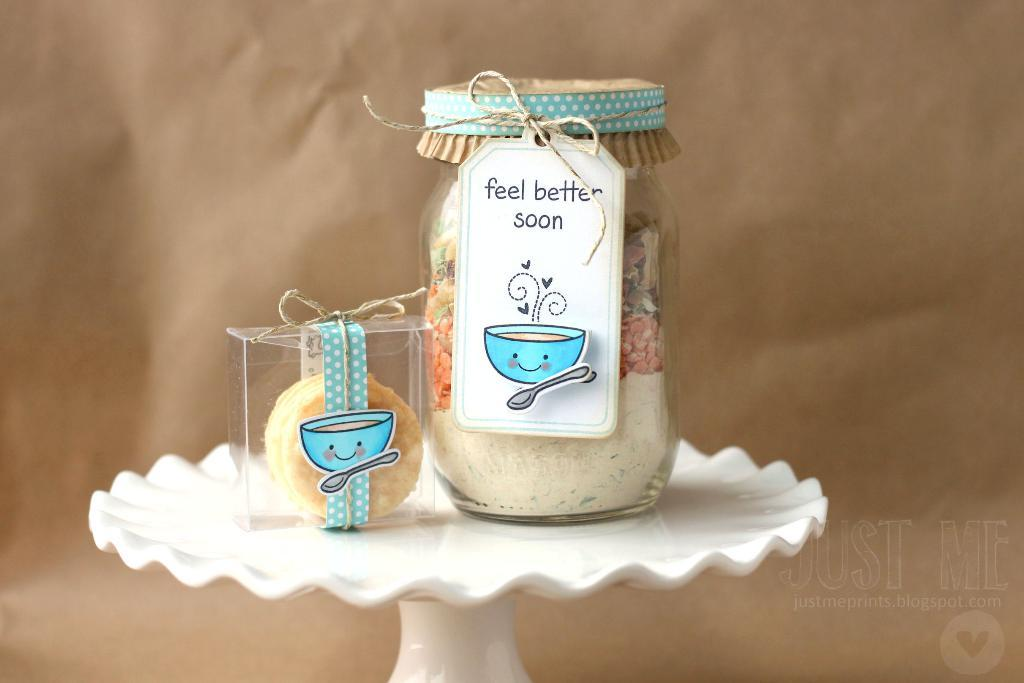<image>
Provide a brief description of the given image. A jar with the words feel better soon written on it. 